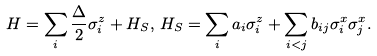<formula> <loc_0><loc_0><loc_500><loc_500>H = \sum _ { i } \frac { \Delta } { 2 } \sigma _ { i } ^ { z } + H _ { S } , \, H _ { S } = \sum _ { i } a _ { i } \sigma _ { i } ^ { z } + \sum _ { i < j } b _ { i j } \sigma ^ { x } _ { i } \sigma ^ { x } _ { j } .</formula> 